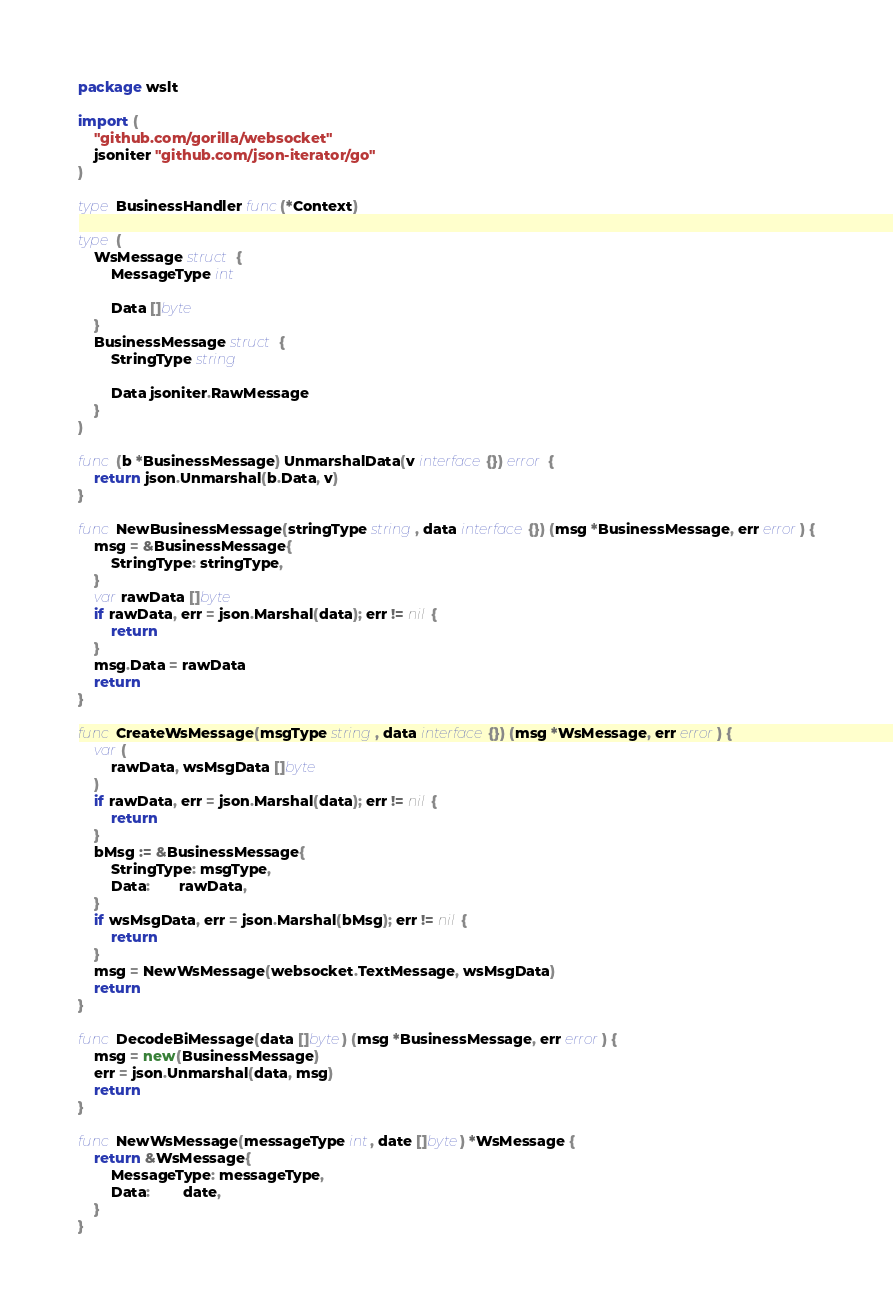<code> <loc_0><loc_0><loc_500><loc_500><_Go_>package wslt

import (
	"github.com/gorilla/websocket"
	jsoniter "github.com/json-iterator/go"
)

type BusinessHandler func(*Context)

type (
	WsMessage struct {
		MessageType int

		Data []byte
	}
	BusinessMessage struct {
		StringType string

		Data jsoniter.RawMessage
	}
)

func (b *BusinessMessage) UnmarshalData(v interface{}) error {
	return json.Unmarshal(b.Data, v)
}

func NewBusinessMessage(stringType string, data interface{}) (msg *BusinessMessage, err error) {
	msg = &BusinessMessage{
		StringType: stringType,
	}
	var rawData []byte
	if rawData, err = json.Marshal(data); err != nil {
		return
	}
	msg.Data = rawData
	return
}

func CreateWsMessage(msgType string, data interface{}) (msg *WsMessage, err error) {
	var (
		rawData, wsMsgData []byte
	)
	if rawData, err = json.Marshal(data); err != nil {
		return
	}
	bMsg := &BusinessMessage{
		StringType: msgType,
		Data:       rawData,
	}
	if wsMsgData, err = json.Marshal(bMsg); err != nil {
		return
	}
	msg = NewWsMessage(websocket.TextMessage, wsMsgData)
	return
}

func DecodeBiMessage(data []byte) (msg *BusinessMessage, err error) {
	msg = new(BusinessMessage)
	err = json.Unmarshal(data, msg)
	return
}

func NewWsMessage(messageType int, date []byte) *WsMessage {
	return &WsMessage{
		MessageType: messageType,
		Data:        date,
	}
}
</code> 